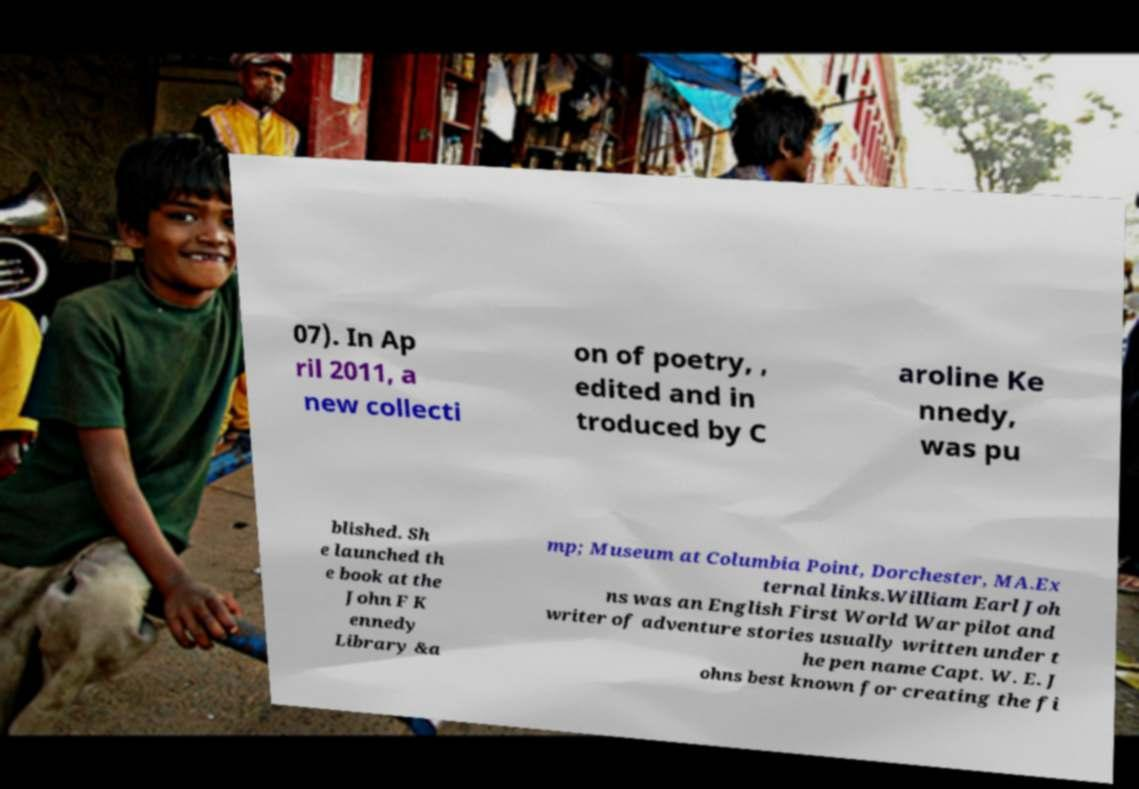I need the written content from this picture converted into text. Can you do that? 07). In Ap ril 2011, a new collecti on of poetry, , edited and in troduced by C aroline Ke nnedy, was pu blished. Sh e launched th e book at the John F K ennedy Library &a mp; Museum at Columbia Point, Dorchester, MA.Ex ternal links.William Earl Joh ns was an English First World War pilot and writer of adventure stories usually written under t he pen name Capt. W. E. J ohns best known for creating the fi 